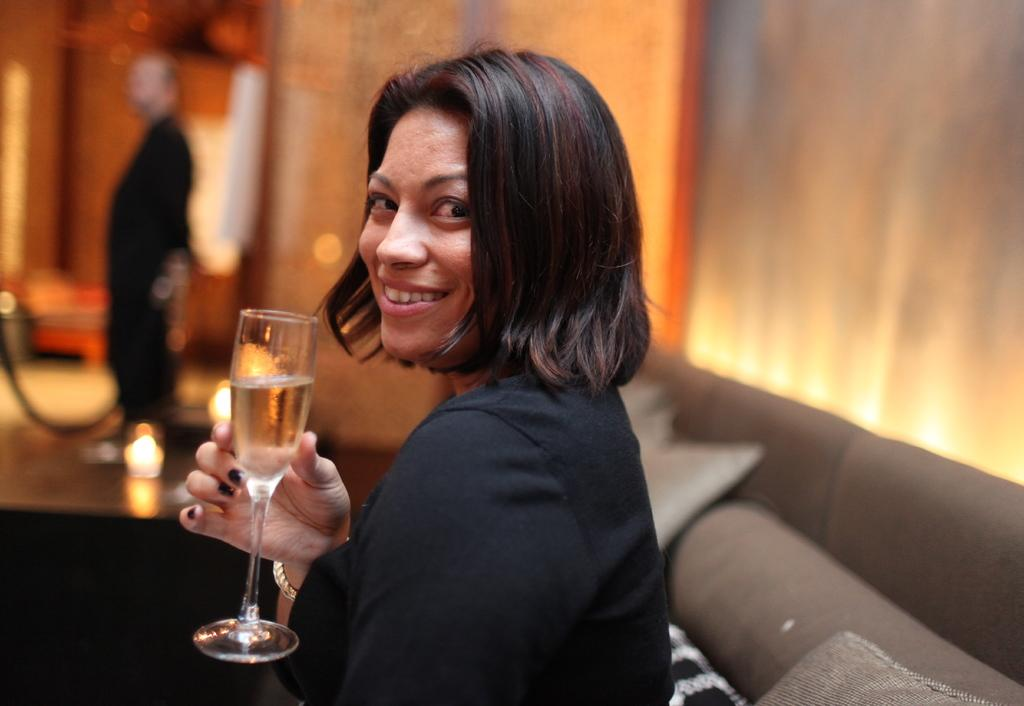Who is present in the image? There is a woman and a man in the image. What is the woman doing in the image? The woman is seated on a sofa and holding a glass in her hands. What type of paper is the woman reading in the image? There is no paper present in the image; the woman is holding a glass in her hands. 